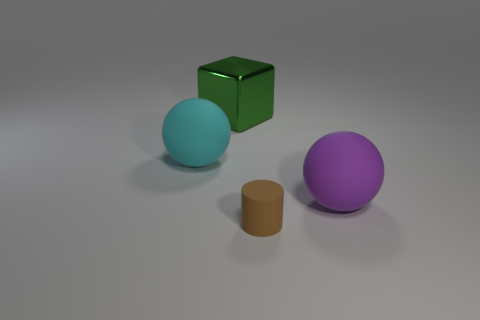Subtract all cyan spheres. How many spheres are left? 1 Add 2 big blue metallic objects. How many objects exist? 6 Subtract all cylinders. How many objects are left? 3 Subtract 2 balls. How many balls are left? 0 Subtract all blue blocks. Subtract all blue cylinders. How many blocks are left? 1 Subtract all purple cylinders. How many purple spheres are left? 1 Subtract all gray shiny objects. Subtract all green objects. How many objects are left? 3 Add 2 large purple things. How many large purple things are left? 3 Add 2 purple rubber balls. How many purple rubber balls exist? 3 Subtract 0 yellow spheres. How many objects are left? 4 